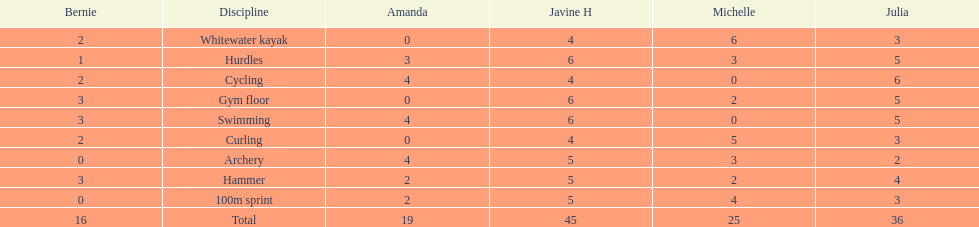What is the average score on 100m sprint? 2.8. 